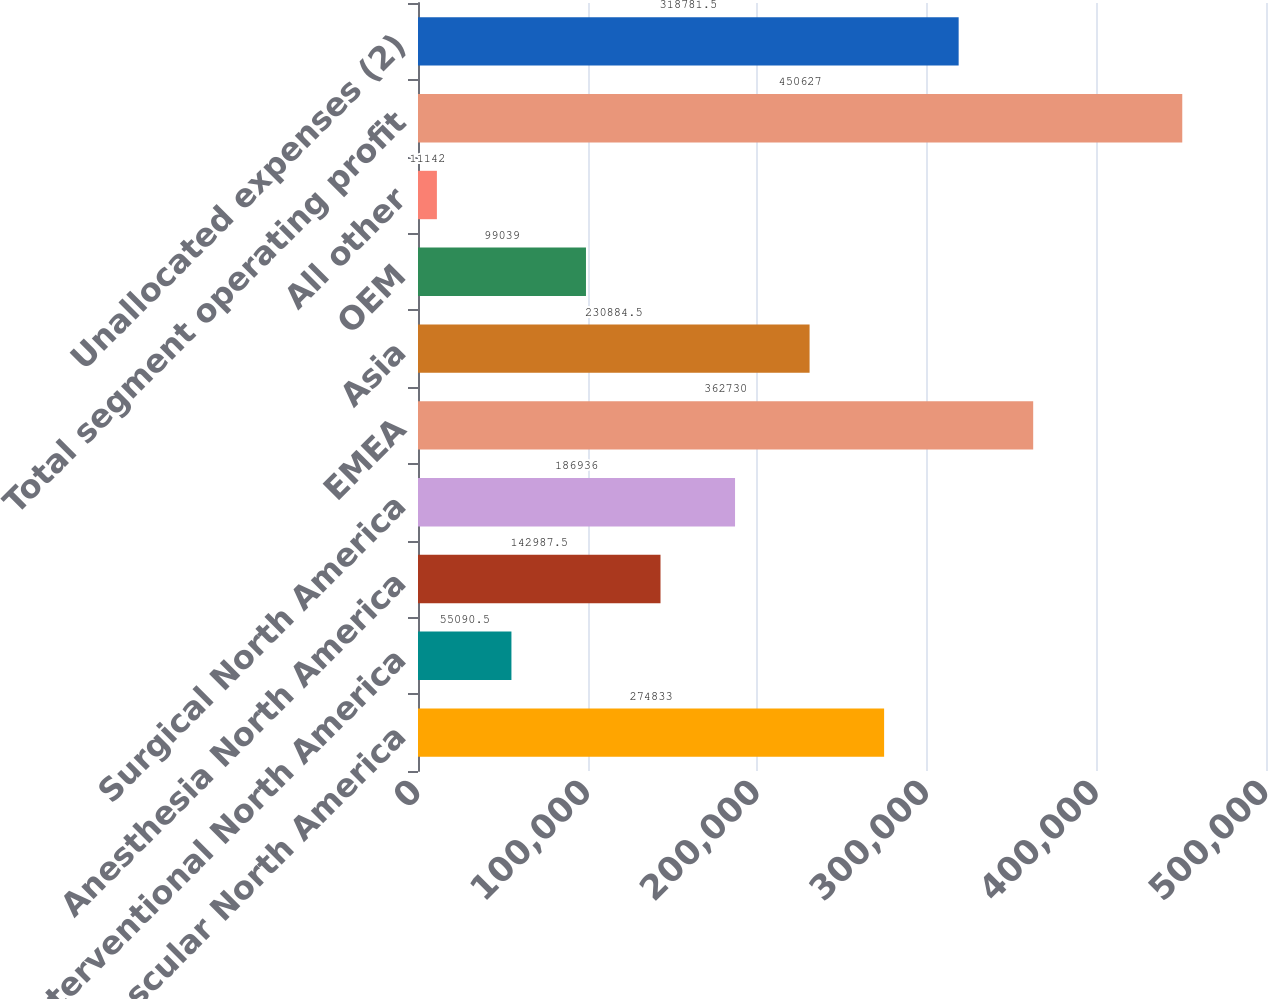Convert chart to OTSL. <chart><loc_0><loc_0><loc_500><loc_500><bar_chart><fcel>Vascular North America<fcel>Interventional North America<fcel>Anesthesia North America<fcel>Surgical North America<fcel>EMEA<fcel>Asia<fcel>OEM<fcel>All other<fcel>Total segment operating profit<fcel>Unallocated expenses (2)<nl><fcel>274833<fcel>55090.5<fcel>142988<fcel>186936<fcel>362730<fcel>230884<fcel>99039<fcel>11142<fcel>450627<fcel>318782<nl></chart> 